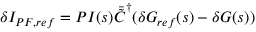<formula> <loc_0><loc_0><loc_500><loc_500>\delta I _ { P F , r e f } = P I ( s ) \ B a r { \tilde { C } } ^ { \dagger } ( \delta G _ { r e f } ( s ) - \delta G ( s ) )</formula> 